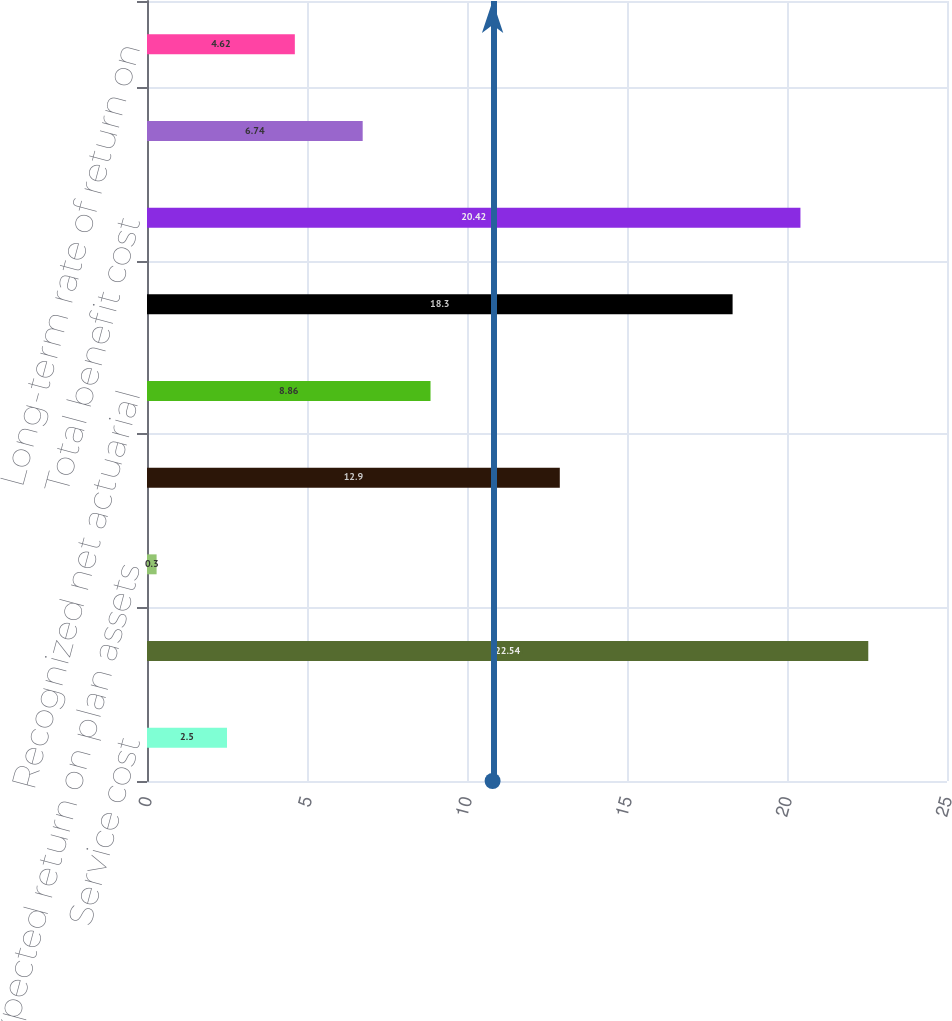Convert chart to OTSL. <chart><loc_0><loc_0><loc_500><loc_500><bar_chart><fcel>Service cost<fcel>Interest cost<fcel>Expected return on plan assets<fcel>Amortization of prior service<fcel>Recognized net actuarial<fcel>Benefit cost-Company plans<fcel>Total benefit cost<fcel>Discount rate<fcel>Long-term rate of return on<nl><fcel>2.5<fcel>22.54<fcel>0.3<fcel>12.9<fcel>8.86<fcel>18.3<fcel>20.42<fcel>6.74<fcel>4.62<nl></chart> 